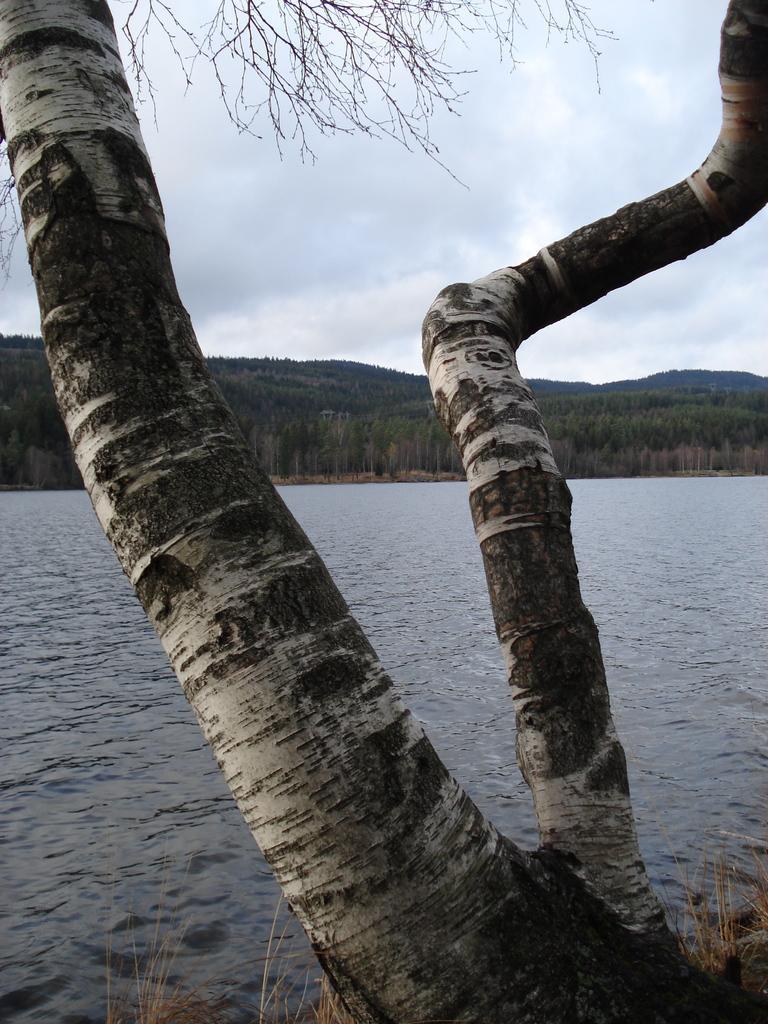How would you summarize this image in a sentence or two? In this image we can see a trunk of a tree. Behind the trunk we can see the water. In the background, we can see a group of trees and mountains. At the top we can see the sky. 